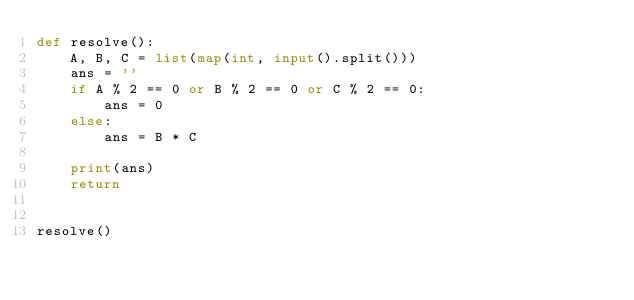<code> <loc_0><loc_0><loc_500><loc_500><_Python_>def resolve():
    A, B, C = list(map(int, input().split()))
    ans = ''
    if A % 2 == 0 or B % 2 == 0 or C % 2 == 0:
        ans = 0
    else:
        ans = B * C

    print(ans)
    return


resolve()</code> 